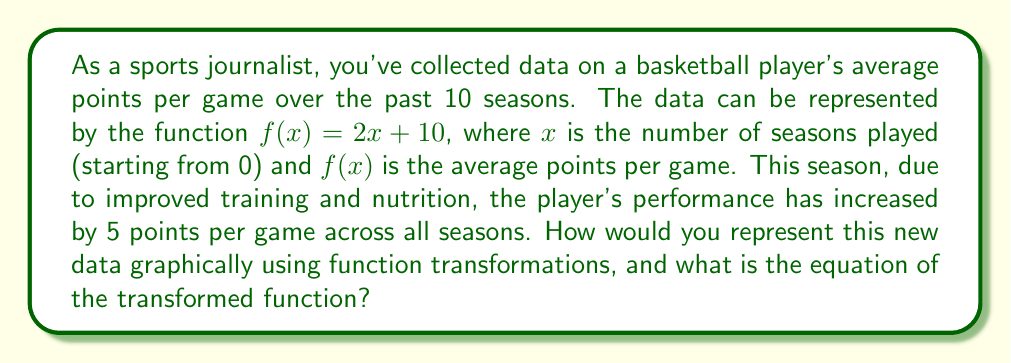Give your solution to this math problem. To solve this problem, we'll follow these steps:

1) The original function is $f(x) = 2x + 10$

2) The player's performance has increased by 5 points per game across all seasons. This means we need to shift the entire function up by 5 units.

3) In function transformation terminology, this is a vertical shift upward by 5 units.

4) The general form for a vertical shift is:
   $g(x) = f(x) + k$, where $k$ is positive for an upward shift and negative for a downward shift.

5) In this case, $k = 5$, so our new function will be:
   $g(x) = f(x) + 5$

6) Substituting the original function:
   $g(x) = (2x + 10) + 5$

7) Simplifying:
   $g(x) = 2x + 15$

8) Graphically, this transformation would shift every point on the original line up by 5 units, resulting in a parallel line 5 units above the original.

[asy]
import graph;
size(200,200);
real f(real x) {return 2x + 10;}
real g(real x) {return 2x + 15;}
draw(graph(f,0,10),blue);
draw(graph(g,0,10),red);
xaxis("x",arrow=Arrow);
yaxis("y",arrow=Arrow);
label("f(x)",(-0.5,11),blue);
label("g(x)",(-0.5,16),red);
[/asy]
Answer: $g(x) = 2x + 15$ 